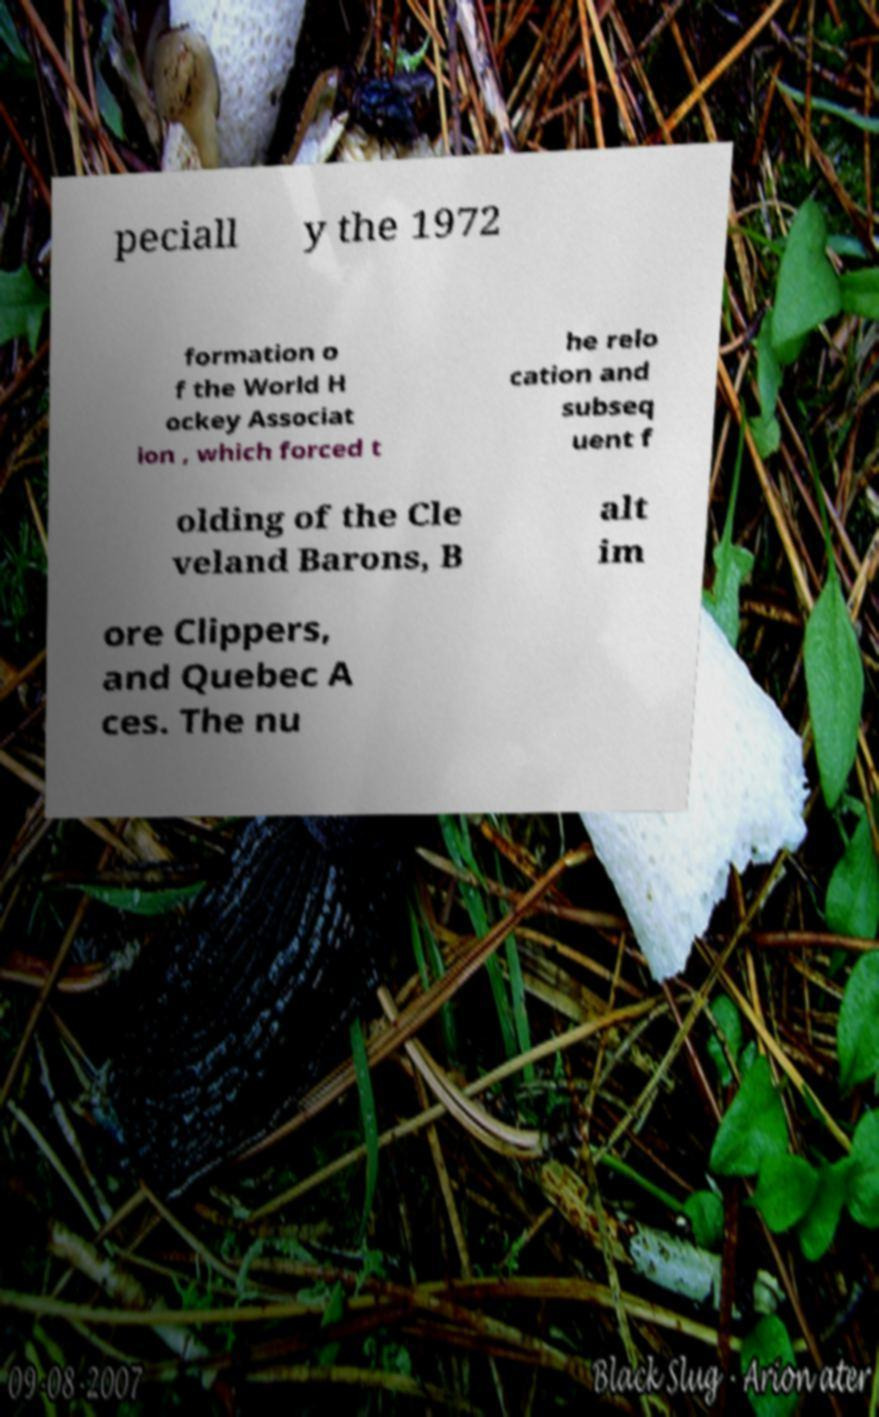Can you accurately transcribe the text from the provided image for me? peciall y the 1972 formation o f the World H ockey Associat ion , which forced t he relo cation and subseq uent f olding of the Cle veland Barons, B alt im ore Clippers, and Quebec A ces. The nu 